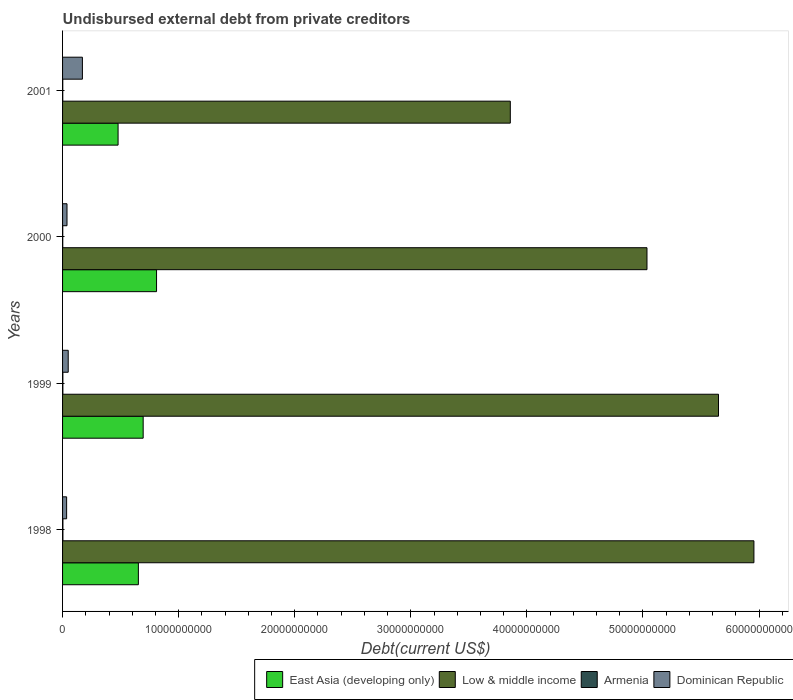How many different coloured bars are there?
Offer a very short reply. 4. How many groups of bars are there?
Offer a very short reply. 4. Are the number of bars per tick equal to the number of legend labels?
Give a very brief answer. Yes. How many bars are there on the 1st tick from the top?
Your answer should be compact. 4. How many bars are there on the 2nd tick from the bottom?
Your answer should be very brief. 4. What is the label of the 3rd group of bars from the top?
Your answer should be compact. 1999. In how many cases, is the number of bars for a given year not equal to the number of legend labels?
Offer a terse response. 0. What is the total debt in Dominican Republic in 1998?
Give a very brief answer. 3.49e+08. Across all years, what is the maximum total debt in East Asia (developing only)?
Keep it short and to the point. 8.10e+09. Across all years, what is the minimum total debt in Armenia?
Your answer should be compact. 1.58e+07. In which year was the total debt in East Asia (developing only) minimum?
Your response must be concise. 2001. What is the total total debt in East Asia (developing only) in the graph?
Provide a succinct answer. 2.64e+1. What is the difference between the total debt in East Asia (developing only) in 1998 and that in 2001?
Your answer should be compact. 1.75e+09. What is the difference between the total debt in East Asia (developing only) in 2000 and the total debt in Dominican Republic in 1998?
Offer a terse response. 7.75e+09. What is the average total debt in East Asia (developing only) per year?
Offer a very short reply. 6.59e+09. In the year 1999, what is the difference between the total debt in East Asia (developing only) and total debt in Dominican Republic?
Your response must be concise. 6.46e+09. In how many years, is the total debt in Low & middle income greater than 58000000000 US$?
Your answer should be compact. 1. What is the ratio of the total debt in Dominican Republic in 1999 to that in 2000?
Your answer should be very brief. 1.27. Is the total debt in Low & middle income in 1999 less than that in 2000?
Your answer should be compact. No. Is the difference between the total debt in East Asia (developing only) in 1999 and 2000 greater than the difference between the total debt in Dominican Republic in 1999 and 2000?
Ensure brevity in your answer.  No. What is the difference between the highest and the second highest total debt in Dominican Republic?
Provide a succinct answer. 1.22e+09. What is the difference between the highest and the lowest total debt in East Asia (developing only)?
Give a very brief answer. 3.31e+09. In how many years, is the total debt in Low & middle income greater than the average total debt in Low & middle income taken over all years?
Keep it short and to the point. 2. Is the sum of the total debt in Dominican Republic in 1998 and 2000 greater than the maximum total debt in Low & middle income across all years?
Your response must be concise. No. Is it the case that in every year, the sum of the total debt in Armenia and total debt in East Asia (developing only) is greater than the total debt in Dominican Republic?
Your response must be concise. Yes. Does the graph contain grids?
Your answer should be very brief. No. How many legend labels are there?
Give a very brief answer. 4. How are the legend labels stacked?
Offer a terse response. Horizontal. What is the title of the graph?
Your answer should be compact. Undisbursed external debt from private creditors. Does "Chile" appear as one of the legend labels in the graph?
Offer a terse response. No. What is the label or title of the X-axis?
Your response must be concise. Debt(current US$). What is the label or title of the Y-axis?
Ensure brevity in your answer.  Years. What is the Debt(current US$) of East Asia (developing only) in 1998?
Your answer should be compact. 6.53e+09. What is the Debt(current US$) in Low & middle income in 1998?
Offer a terse response. 5.96e+1. What is the Debt(current US$) in Armenia in 1998?
Give a very brief answer. 3.00e+07. What is the Debt(current US$) of Dominican Republic in 1998?
Keep it short and to the point. 3.49e+08. What is the Debt(current US$) in East Asia (developing only) in 1999?
Offer a very short reply. 6.94e+09. What is the Debt(current US$) in Low & middle income in 1999?
Offer a terse response. 5.65e+1. What is the Debt(current US$) of Armenia in 1999?
Keep it short and to the point. 2.61e+07. What is the Debt(current US$) in Dominican Republic in 1999?
Make the answer very short. 4.88e+08. What is the Debt(current US$) of East Asia (developing only) in 2000?
Keep it short and to the point. 8.10e+09. What is the Debt(current US$) in Low & middle income in 2000?
Your answer should be compact. 5.03e+1. What is the Debt(current US$) in Armenia in 2000?
Your answer should be compact. 1.58e+07. What is the Debt(current US$) in Dominican Republic in 2000?
Provide a succinct answer. 3.83e+08. What is the Debt(current US$) in East Asia (developing only) in 2001?
Offer a very short reply. 4.78e+09. What is the Debt(current US$) of Low & middle income in 2001?
Ensure brevity in your answer.  3.86e+1. What is the Debt(current US$) of Armenia in 2001?
Your answer should be very brief. 1.67e+07. What is the Debt(current US$) of Dominican Republic in 2001?
Offer a terse response. 1.71e+09. Across all years, what is the maximum Debt(current US$) in East Asia (developing only)?
Your answer should be compact. 8.10e+09. Across all years, what is the maximum Debt(current US$) in Low & middle income?
Give a very brief answer. 5.96e+1. Across all years, what is the maximum Debt(current US$) of Armenia?
Offer a terse response. 3.00e+07. Across all years, what is the maximum Debt(current US$) of Dominican Republic?
Provide a short and direct response. 1.71e+09. Across all years, what is the minimum Debt(current US$) of East Asia (developing only)?
Offer a terse response. 4.78e+09. Across all years, what is the minimum Debt(current US$) in Low & middle income?
Ensure brevity in your answer.  3.86e+1. Across all years, what is the minimum Debt(current US$) of Armenia?
Provide a succinct answer. 1.58e+07. Across all years, what is the minimum Debt(current US$) in Dominican Republic?
Your response must be concise. 3.49e+08. What is the total Debt(current US$) of East Asia (developing only) in the graph?
Give a very brief answer. 2.64e+1. What is the total Debt(current US$) in Low & middle income in the graph?
Make the answer very short. 2.05e+11. What is the total Debt(current US$) in Armenia in the graph?
Your response must be concise. 8.86e+07. What is the total Debt(current US$) of Dominican Republic in the graph?
Your answer should be very brief. 2.93e+09. What is the difference between the Debt(current US$) in East Asia (developing only) in 1998 and that in 1999?
Provide a short and direct response. -4.13e+08. What is the difference between the Debt(current US$) of Low & middle income in 1998 and that in 1999?
Give a very brief answer. 3.05e+09. What is the difference between the Debt(current US$) in Armenia in 1998 and that in 1999?
Keep it short and to the point. 3.90e+06. What is the difference between the Debt(current US$) of Dominican Republic in 1998 and that in 1999?
Offer a terse response. -1.38e+08. What is the difference between the Debt(current US$) in East Asia (developing only) in 1998 and that in 2000?
Make the answer very short. -1.57e+09. What is the difference between the Debt(current US$) in Low & middle income in 1998 and that in 2000?
Ensure brevity in your answer.  9.21e+09. What is the difference between the Debt(current US$) in Armenia in 1998 and that in 2000?
Provide a succinct answer. 1.42e+07. What is the difference between the Debt(current US$) of Dominican Republic in 1998 and that in 2000?
Provide a succinct answer. -3.33e+07. What is the difference between the Debt(current US$) of East Asia (developing only) in 1998 and that in 2001?
Your answer should be very brief. 1.75e+09. What is the difference between the Debt(current US$) in Low & middle income in 1998 and that in 2001?
Make the answer very short. 2.10e+1. What is the difference between the Debt(current US$) in Armenia in 1998 and that in 2001?
Make the answer very short. 1.33e+07. What is the difference between the Debt(current US$) of Dominican Republic in 1998 and that in 2001?
Your answer should be compact. -1.36e+09. What is the difference between the Debt(current US$) of East Asia (developing only) in 1999 and that in 2000?
Provide a succinct answer. -1.15e+09. What is the difference between the Debt(current US$) of Low & middle income in 1999 and that in 2000?
Make the answer very short. 6.16e+09. What is the difference between the Debt(current US$) of Armenia in 1999 and that in 2000?
Your answer should be very brief. 1.04e+07. What is the difference between the Debt(current US$) of Dominican Republic in 1999 and that in 2000?
Provide a succinct answer. 1.05e+08. What is the difference between the Debt(current US$) of East Asia (developing only) in 1999 and that in 2001?
Offer a terse response. 2.16e+09. What is the difference between the Debt(current US$) of Low & middle income in 1999 and that in 2001?
Offer a terse response. 1.79e+1. What is the difference between the Debt(current US$) of Armenia in 1999 and that in 2001?
Provide a short and direct response. 9.39e+06. What is the difference between the Debt(current US$) in Dominican Republic in 1999 and that in 2001?
Your answer should be very brief. -1.22e+09. What is the difference between the Debt(current US$) in East Asia (developing only) in 2000 and that in 2001?
Offer a very short reply. 3.31e+09. What is the difference between the Debt(current US$) of Low & middle income in 2000 and that in 2001?
Offer a terse response. 1.18e+1. What is the difference between the Debt(current US$) of Armenia in 2000 and that in 2001?
Give a very brief answer. -9.60e+05. What is the difference between the Debt(current US$) in Dominican Republic in 2000 and that in 2001?
Keep it short and to the point. -1.33e+09. What is the difference between the Debt(current US$) in East Asia (developing only) in 1998 and the Debt(current US$) in Low & middle income in 1999?
Provide a short and direct response. -5.00e+1. What is the difference between the Debt(current US$) in East Asia (developing only) in 1998 and the Debt(current US$) in Armenia in 1999?
Your answer should be compact. 6.50e+09. What is the difference between the Debt(current US$) of East Asia (developing only) in 1998 and the Debt(current US$) of Dominican Republic in 1999?
Your response must be concise. 6.04e+09. What is the difference between the Debt(current US$) of Low & middle income in 1998 and the Debt(current US$) of Armenia in 1999?
Provide a succinct answer. 5.95e+1. What is the difference between the Debt(current US$) of Low & middle income in 1998 and the Debt(current US$) of Dominican Republic in 1999?
Ensure brevity in your answer.  5.91e+1. What is the difference between the Debt(current US$) of Armenia in 1998 and the Debt(current US$) of Dominican Republic in 1999?
Offer a very short reply. -4.58e+08. What is the difference between the Debt(current US$) of East Asia (developing only) in 1998 and the Debt(current US$) of Low & middle income in 2000?
Give a very brief answer. -4.38e+1. What is the difference between the Debt(current US$) in East Asia (developing only) in 1998 and the Debt(current US$) in Armenia in 2000?
Your answer should be compact. 6.51e+09. What is the difference between the Debt(current US$) of East Asia (developing only) in 1998 and the Debt(current US$) of Dominican Republic in 2000?
Provide a succinct answer. 6.15e+09. What is the difference between the Debt(current US$) in Low & middle income in 1998 and the Debt(current US$) in Armenia in 2000?
Offer a very short reply. 5.95e+1. What is the difference between the Debt(current US$) of Low & middle income in 1998 and the Debt(current US$) of Dominican Republic in 2000?
Offer a very short reply. 5.92e+1. What is the difference between the Debt(current US$) in Armenia in 1998 and the Debt(current US$) in Dominican Republic in 2000?
Your answer should be compact. -3.53e+08. What is the difference between the Debt(current US$) of East Asia (developing only) in 1998 and the Debt(current US$) of Low & middle income in 2001?
Make the answer very short. -3.20e+1. What is the difference between the Debt(current US$) of East Asia (developing only) in 1998 and the Debt(current US$) of Armenia in 2001?
Provide a short and direct response. 6.51e+09. What is the difference between the Debt(current US$) in East Asia (developing only) in 1998 and the Debt(current US$) in Dominican Republic in 2001?
Ensure brevity in your answer.  4.82e+09. What is the difference between the Debt(current US$) in Low & middle income in 1998 and the Debt(current US$) in Armenia in 2001?
Provide a succinct answer. 5.95e+1. What is the difference between the Debt(current US$) of Low & middle income in 1998 and the Debt(current US$) of Dominican Republic in 2001?
Provide a succinct answer. 5.79e+1. What is the difference between the Debt(current US$) of Armenia in 1998 and the Debt(current US$) of Dominican Republic in 2001?
Ensure brevity in your answer.  -1.68e+09. What is the difference between the Debt(current US$) in East Asia (developing only) in 1999 and the Debt(current US$) in Low & middle income in 2000?
Your response must be concise. -4.34e+1. What is the difference between the Debt(current US$) in East Asia (developing only) in 1999 and the Debt(current US$) in Armenia in 2000?
Provide a succinct answer. 6.93e+09. What is the difference between the Debt(current US$) of East Asia (developing only) in 1999 and the Debt(current US$) of Dominican Republic in 2000?
Keep it short and to the point. 6.56e+09. What is the difference between the Debt(current US$) in Low & middle income in 1999 and the Debt(current US$) in Armenia in 2000?
Provide a short and direct response. 5.65e+1. What is the difference between the Debt(current US$) of Low & middle income in 1999 and the Debt(current US$) of Dominican Republic in 2000?
Make the answer very short. 5.61e+1. What is the difference between the Debt(current US$) in Armenia in 1999 and the Debt(current US$) in Dominican Republic in 2000?
Offer a terse response. -3.57e+08. What is the difference between the Debt(current US$) of East Asia (developing only) in 1999 and the Debt(current US$) of Low & middle income in 2001?
Provide a short and direct response. -3.16e+1. What is the difference between the Debt(current US$) in East Asia (developing only) in 1999 and the Debt(current US$) in Armenia in 2001?
Your response must be concise. 6.93e+09. What is the difference between the Debt(current US$) of East Asia (developing only) in 1999 and the Debt(current US$) of Dominican Republic in 2001?
Provide a short and direct response. 5.23e+09. What is the difference between the Debt(current US$) in Low & middle income in 1999 and the Debt(current US$) in Armenia in 2001?
Keep it short and to the point. 5.65e+1. What is the difference between the Debt(current US$) of Low & middle income in 1999 and the Debt(current US$) of Dominican Republic in 2001?
Ensure brevity in your answer.  5.48e+1. What is the difference between the Debt(current US$) in Armenia in 1999 and the Debt(current US$) in Dominican Republic in 2001?
Keep it short and to the point. -1.68e+09. What is the difference between the Debt(current US$) in East Asia (developing only) in 2000 and the Debt(current US$) in Low & middle income in 2001?
Give a very brief answer. -3.05e+1. What is the difference between the Debt(current US$) of East Asia (developing only) in 2000 and the Debt(current US$) of Armenia in 2001?
Provide a succinct answer. 8.08e+09. What is the difference between the Debt(current US$) in East Asia (developing only) in 2000 and the Debt(current US$) in Dominican Republic in 2001?
Your answer should be very brief. 6.39e+09. What is the difference between the Debt(current US$) of Low & middle income in 2000 and the Debt(current US$) of Armenia in 2001?
Provide a short and direct response. 5.03e+1. What is the difference between the Debt(current US$) in Low & middle income in 2000 and the Debt(current US$) in Dominican Republic in 2001?
Provide a short and direct response. 4.86e+1. What is the difference between the Debt(current US$) of Armenia in 2000 and the Debt(current US$) of Dominican Republic in 2001?
Make the answer very short. -1.69e+09. What is the average Debt(current US$) of East Asia (developing only) per year?
Give a very brief answer. 6.59e+09. What is the average Debt(current US$) of Low & middle income per year?
Offer a very short reply. 5.12e+1. What is the average Debt(current US$) of Armenia per year?
Offer a very short reply. 2.21e+07. What is the average Debt(current US$) of Dominican Republic per year?
Your response must be concise. 7.32e+08. In the year 1998, what is the difference between the Debt(current US$) in East Asia (developing only) and Debt(current US$) in Low & middle income?
Ensure brevity in your answer.  -5.30e+1. In the year 1998, what is the difference between the Debt(current US$) in East Asia (developing only) and Debt(current US$) in Armenia?
Offer a terse response. 6.50e+09. In the year 1998, what is the difference between the Debt(current US$) in East Asia (developing only) and Debt(current US$) in Dominican Republic?
Give a very brief answer. 6.18e+09. In the year 1998, what is the difference between the Debt(current US$) of Low & middle income and Debt(current US$) of Armenia?
Your answer should be compact. 5.95e+1. In the year 1998, what is the difference between the Debt(current US$) of Low & middle income and Debt(current US$) of Dominican Republic?
Your answer should be very brief. 5.92e+1. In the year 1998, what is the difference between the Debt(current US$) of Armenia and Debt(current US$) of Dominican Republic?
Your answer should be compact. -3.19e+08. In the year 1999, what is the difference between the Debt(current US$) in East Asia (developing only) and Debt(current US$) in Low & middle income?
Ensure brevity in your answer.  -4.96e+1. In the year 1999, what is the difference between the Debt(current US$) of East Asia (developing only) and Debt(current US$) of Armenia?
Your answer should be compact. 6.92e+09. In the year 1999, what is the difference between the Debt(current US$) in East Asia (developing only) and Debt(current US$) in Dominican Republic?
Keep it short and to the point. 6.46e+09. In the year 1999, what is the difference between the Debt(current US$) in Low & middle income and Debt(current US$) in Armenia?
Provide a short and direct response. 5.65e+1. In the year 1999, what is the difference between the Debt(current US$) of Low & middle income and Debt(current US$) of Dominican Republic?
Your answer should be compact. 5.60e+1. In the year 1999, what is the difference between the Debt(current US$) of Armenia and Debt(current US$) of Dominican Republic?
Provide a short and direct response. -4.61e+08. In the year 2000, what is the difference between the Debt(current US$) of East Asia (developing only) and Debt(current US$) of Low & middle income?
Ensure brevity in your answer.  -4.23e+1. In the year 2000, what is the difference between the Debt(current US$) in East Asia (developing only) and Debt(current US$) in Armenia?
Offer a terse response. 8.08e+09. In the year 2000, what is the difference between the Debt(current US$) of East Asia (developing only) and Debt(current US$) of Dominican Republic?
Keep it short and to the point. 7.71e+09. In the year 2000, what is the difference between the Debt(current US$) of Low & middle income and Debt(current US$) of Armenia?
Provide a succinct answer. 5.03e+1. In the year 2000, what is the difference between the Debt(current US$) in Low & middle income and Debt(current US$) in Dominican Republic?
Keep it short and to the point. 5.00e+1. In the year 2000, what is the difference between the Debt(current US$) of Armenia and Debt(current US$) of Dominican Republic?
Your response must be concise. -3.67e+08. In the year 2001, what is the difference between the Debt(current US$) of East Asia (developing only) and Debt(current US$) of Low & middle income?
Your answer should be compact. -3.38e+1. In the year 2001, what is the difference between the Debt(current US$) of East Asia (developing only) and Debt(current US$) of Armenia?
Your answer should be very brief. 4.77e+09. In the year 2001, what is the difference between the Debt(current US$) in East Asia (developing only) and Debt(current US$) in Dominican Republic?
Provide a short and direct response. 3.07e+09. In the year 2001, what is the difference between the Debt(current US$) in Low & middle income and Debt(current US$) in Armenia?
Offer a terse response. 3.86e+1. In the year 2001, what is the difference between the Debt(current US$) in Low & middle income and Debt(current US$) in Dominican Republic?
Provide a succinct answer. 3.69e+1. In the year 2001, what is the difference between the Debt(current US$) of Armenia and Debt(current US$) of Dominican Republic?
Provide a succinct answer. -1.69e+09. What is the ratio of the Debt(current US$) in East Asia (developing only) in 1998 to that in 1999?
Your response must be concise. 0.94. What is the ratio of the Debt(current US$) of Low & middle income in 1998 to that in 1999?
Ensure brevity in your answer.  1.05. What is the ratio of the Debt(current US$) in Armenia in 1998 to that in 1999?
Your answer should be very brief. 1.15. What is the ratio of the Debt(current US$) of Dominican Republic in 1998 to that in 1999?
Ensure brevity in your answer.  0.72. What is the ratio of the Debt(current US$) of East Asia (developing only) in 1998 to that in 2000?
Offer a terse response. 0.81. What is the ratio of the Debt(current US$) in Low & middle income in 1998 to that in 2000?
Make the answer very short. 1.18. What is the ratio of the Debt(current US$) in Armenia in 1998 to that in 2000?
Provide a short and direct response. 1.9. What is the ratio of the Debt(current US$) of Dominican Republic in 1998 to that in 2000?
Make the answer very short. 0.91. What is the ratio of the Debt(current US$) in East Asia (developing only) in 1998 to that in 2001?
Give a very brief answer. 1.37. What is the ratio of the Debt(current US$) in Low & middle income in 1998 to that in 2001?
Give a very brief answer. 1.54. What is the ratio of the Debt(current US$) in Armenia in 1998 to that in 2001?
Ensure brevity in your answer.  1.8. What is the ratio of the Debt(current US$) in Dominican Republic in 1998 to that in 2001?
Your answer should be compact. 0.2. What is the ratio of the Debt(current US$) of East Asia (developing only) in 1999 to that in 2000?
Provide a succinct answer. 0.86. What is the ratio of the Debt(current US$) in Low & middle income in 1999 to that in 2000?
Provide a short and direct response. 1.12. What is the ratio of the Debt(current US$) of Armenia in 1999 to that in 2000?
Your response must be concise. 1.66. What is the ratio of the Debt(current US$) of Dominican Republic in 1999 to that in 2000?
Make the answer very short. 1.27. What is the ratio of the Debt(current US$) of East Asia (developing only) in 1999 to that in 2001?
Your response must be concise. 1.45. What is the ratio of the Debt(current US$) of Low & middle income in 1999 to that in 2001?
Your response must be concise. 1.47. What is the ratio of the Debt(current US$) in Armenia in 1999 to that in 2001?
Make the answer very short. 1.56. What is the ratio of the Debt(current US$) of Dominican Republic in 1999 to that in 2001?
Give a very brief answer. 0.29. What is the ratio of the Debt(current US$) in East Asia (developing only) in 2000 to that in 2001?
Your answer should be compact. 1.69. What is the ratio of the Debt(current US$) in Low & middle income in 2000 to that in 2001?
Your answer should be compact. 1.31. What is the ratio of the Debt(current US$) in Armenia in 2000 to that in 2001?
Provide a short and direct response. 0.94. What is the ratio of the Debt(current US$) in Dominican Republic in 2000 to that in 2001?
Provide a short and direct response. 0.22. What is the difference between the highest and the second highest Debt(current US$) of East Asia (developing only)?
Your response must be concise. 1.15e+09. What is the difference between the highest and the second highest Debt(current US$) in Low & middle income?
Provide a short and direct response. 3.05e+09. What is the difference between the highest and the second highest Debt(current US$) of Armenia?
Make the answer very short. 3.90e+06. What is the difference between the highest and the second highest Debt(current US$) in Dominican Republic?
Give a very brief answer. 1.22e+09. What is the difference between the highest and the lowest Debt(current US$) of East Asia (developing only)?
Offer a very short reply. 3.31e+09. What is the difference between the highest and the lowest Debt(current US$) of Low & middle income?
Make the answer very short. 2.10e+1. What is the difference between the highest and the lowest Debt(current US$) in Armenia?
Make the answer very short. 1.42e+07. What is the difference between the highest and the lowest Debt(current US$) of Dominican Republic?
Provide a short and direct response. 1.36e+09. 